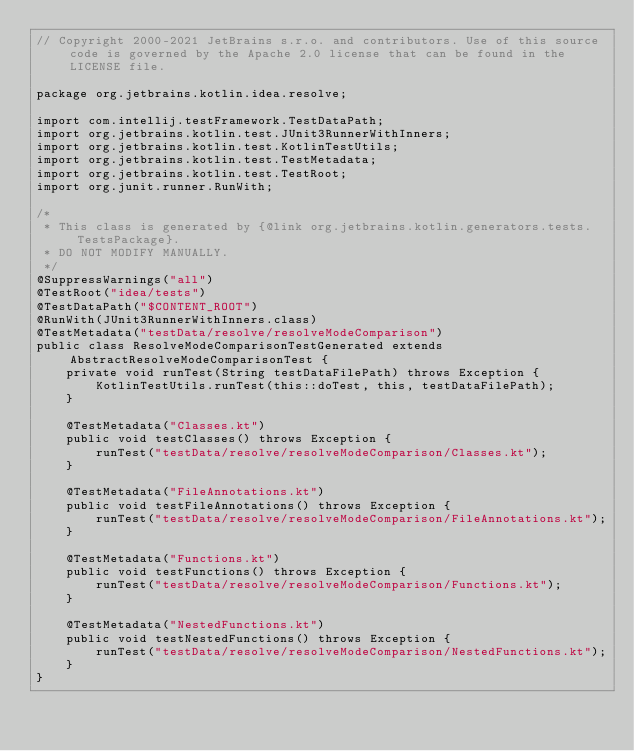<code> <loc_0><loc_0><loc_500><loc_500><_Java_>// Copyright 2000-2021 JetBrains s.r.o. and contributors. Use of this source code is governed by the Apache 2.0 license that can be found in the LICENSE file.

package org.jetbrains.kotlin.idea.resolve;

import com.intellij.testFramework.TestDataPath;
import org.jetbrains.kotlin.test.JUnit3RunnerWithInners;
import org.jetbrains.kotlin.test.KotlinTestUtils;
import org.jetbrains.kotlin.test.TestMetadata;
import org.jetbrains.kotlin.test.TestRoot;
import org.junit.runner.RunWith;

/*
 * This class is generated by {@link org.jetbrains.kotlin.generators.tests.TestsPackage}.
 * DO NOT MODIFY MANUALLY.
 */
@SuppressWarnings("all")
@TestRoot("idea/tests")
@TestDataPath("$CONTENT_ROOT")
@RunWith(JUnit3RunnerWithInners.class)
@TestMetadata("testData/resolve/resolveModeComparison")
public class ResolveModeComparisonTestGenerated extends AbstractResolveModeComparisonTest {
    private void runTest(String testDataFilePath) throws Exception {
        KotlinTestUtils.runTest(this::doTest, this, testDataFilePath);
    }

    @TestMetadata("Classes.kt")
    public void testClasses() throws Exception {
        runTest("testData/resolve/resolveModeComparison/Classes.kt");
    }

    @TestMetadata("FileAnnotations.kt")
    public void testFileAnnotations() throws Exception {
        runTest("testData/resolve/resolveModeComparison/FileAnnotations.kt");
    }

    @TestMetadata("Functions.kt")
    public void testFunctions() throws Exception {
        runTest("testData/resolve/resolveModeComparison/Functions.kt");
    }

    @TestMetadata("NestedFunctions.kt")
    public void testNestedFunctions() throws Exception {
        runTest("testData/resolve/resolveModeComparison/NestedFunctions.kt");
    }
}
</code> 